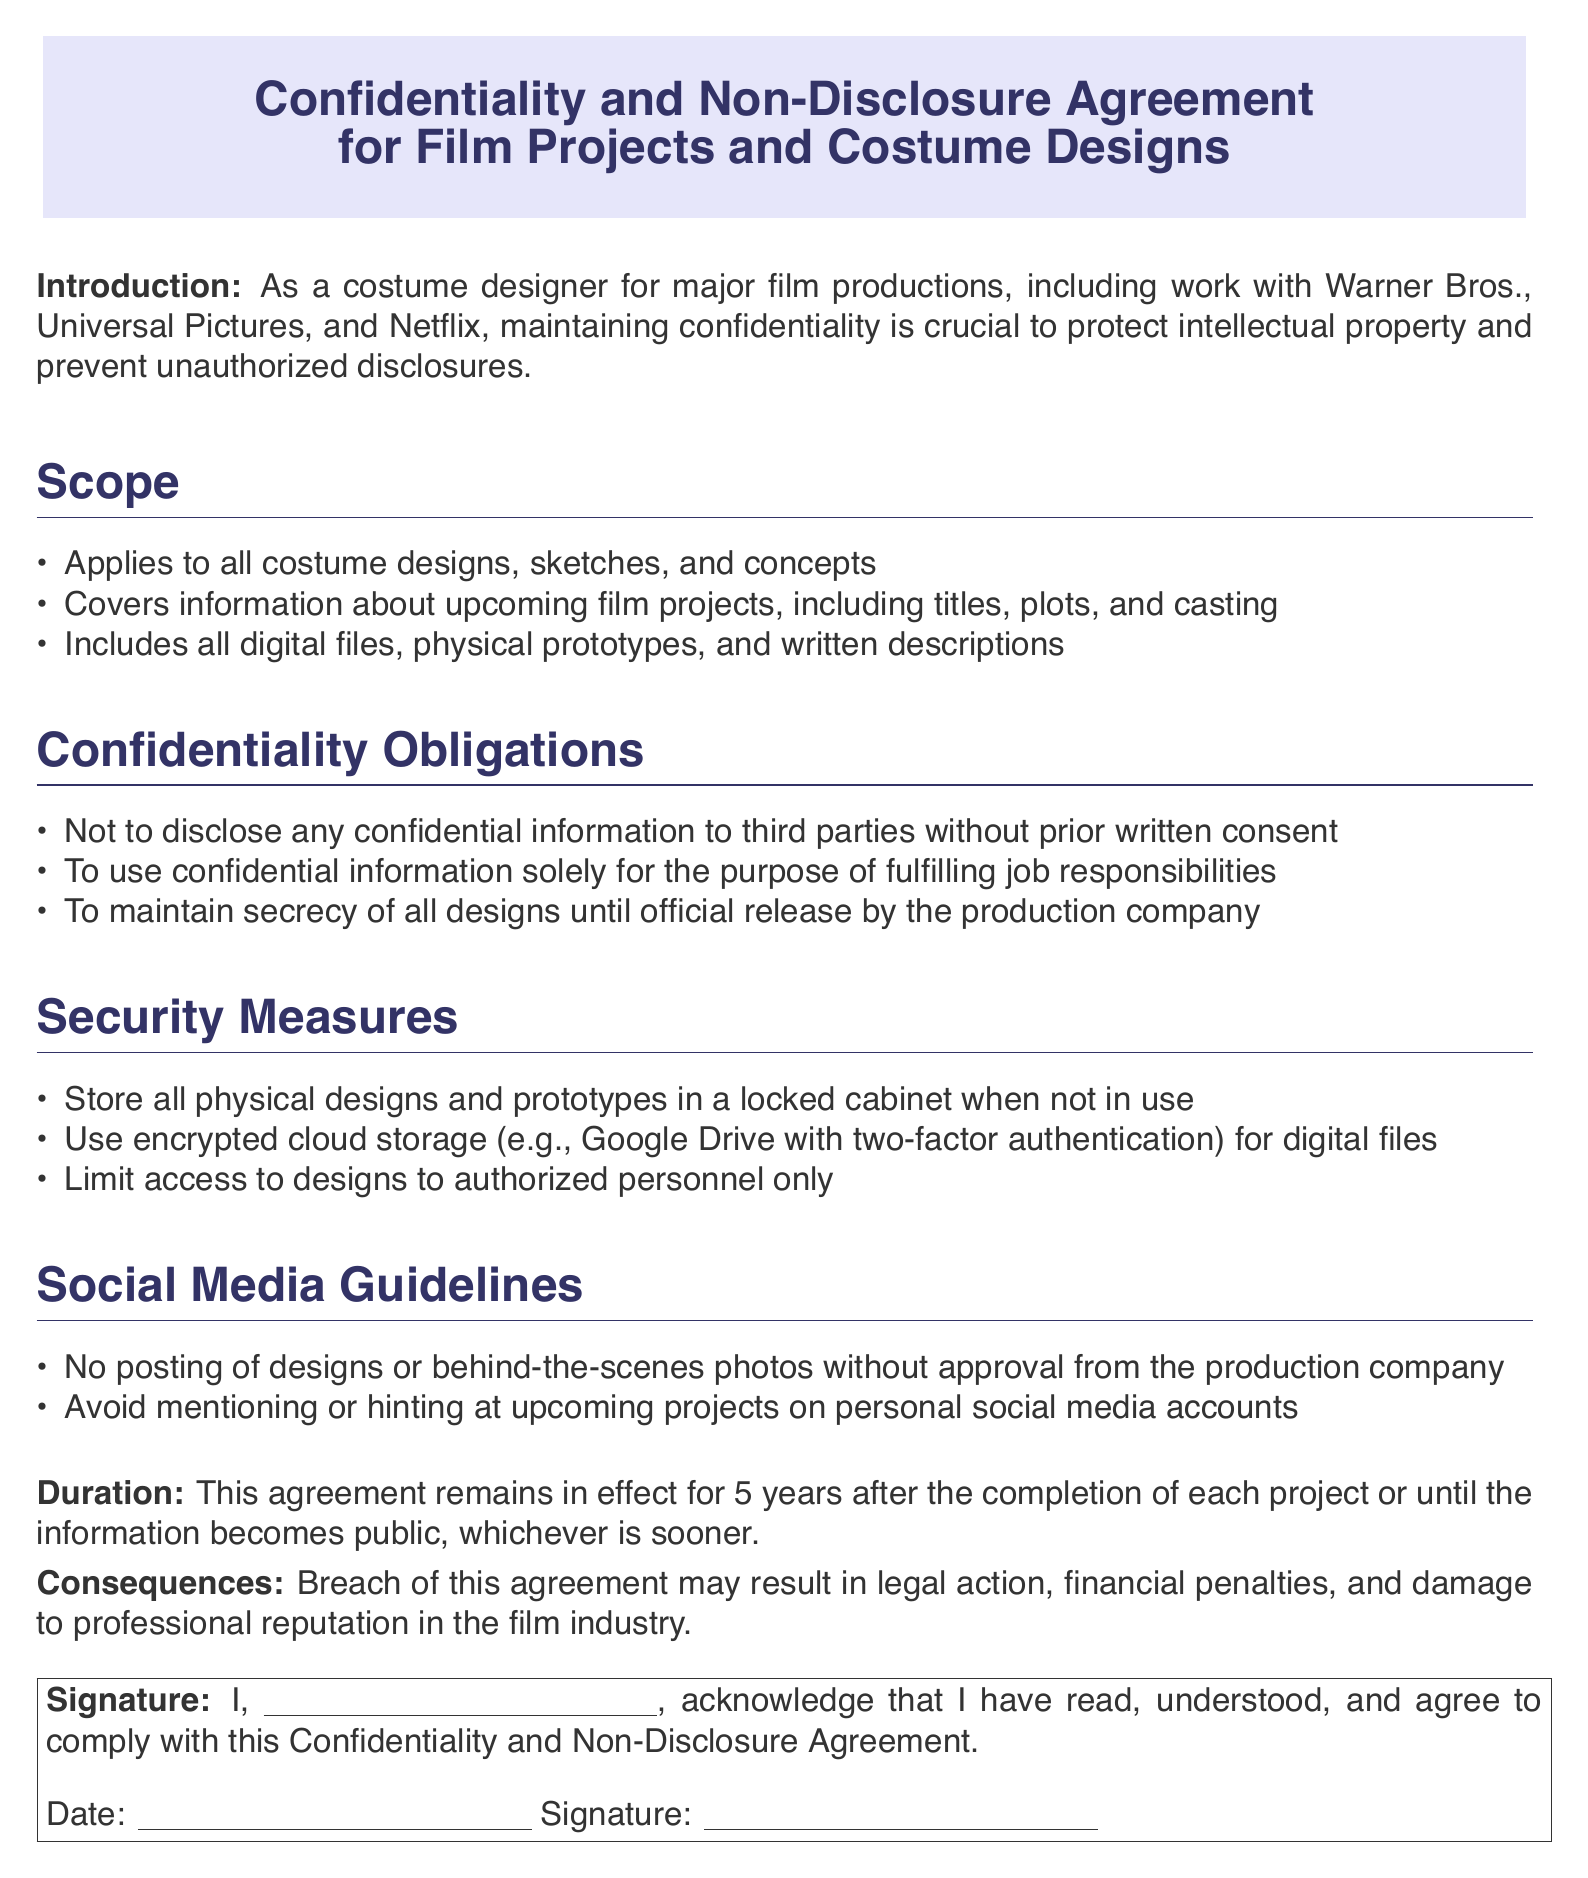What is the main purpose of this document? The document outlines the guidelines and responsibilities related to confidentiality and non-disclosure for costume designers working on film projects.
Answer: Confidentiality and Non-Disclosure Agreement What types of information does this agreement cover? The agreement applies to costume designs, sketches, concepts, and information about upcoming film projects.
Answer: All costume designs, sketches, and concepts What security measure is suggested for digital files? The document specifies the use of encrypted cloud storage with two-factor authentication for digital files.
Answer: Encrypted cloud storage How long does the confidentiality agreement remain in effect? The duration of the agreement is specified as lasting for 5 years after project completion or until information becomes public.
Answer: 5 years What is a consequence of breaching this agreement? The document states that breaching the agreement may lead to legal action or financial penalties.
Answer: Legal action Who must approve social media posts about designs? The document indicates that the production company must approve any posts regarding designs or behind-the-scenes photos.
Answer: Production company What type of storage is recommended for physical designs? The agreement recommends storing physical designs in a locked cabinet when not in use.
Answer: Locked cabinet How should confidential information be used according to the obligations? According to the obligations, confidential information should only be used for fulfilling job responsibilities.
Answer: Job responsibilities only 